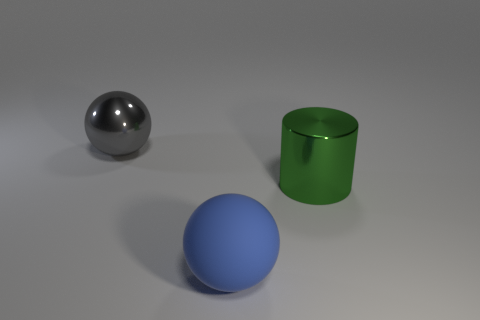How would you describe the lighting and the shadows in the scene? The lighting in the scene appears to be soft and diffused, coming from the upper left side, which creates gentle shadows on the right side of the objects. This suggests that the light source is not very intense or is possibly filtered through a semi-transparent medium. 